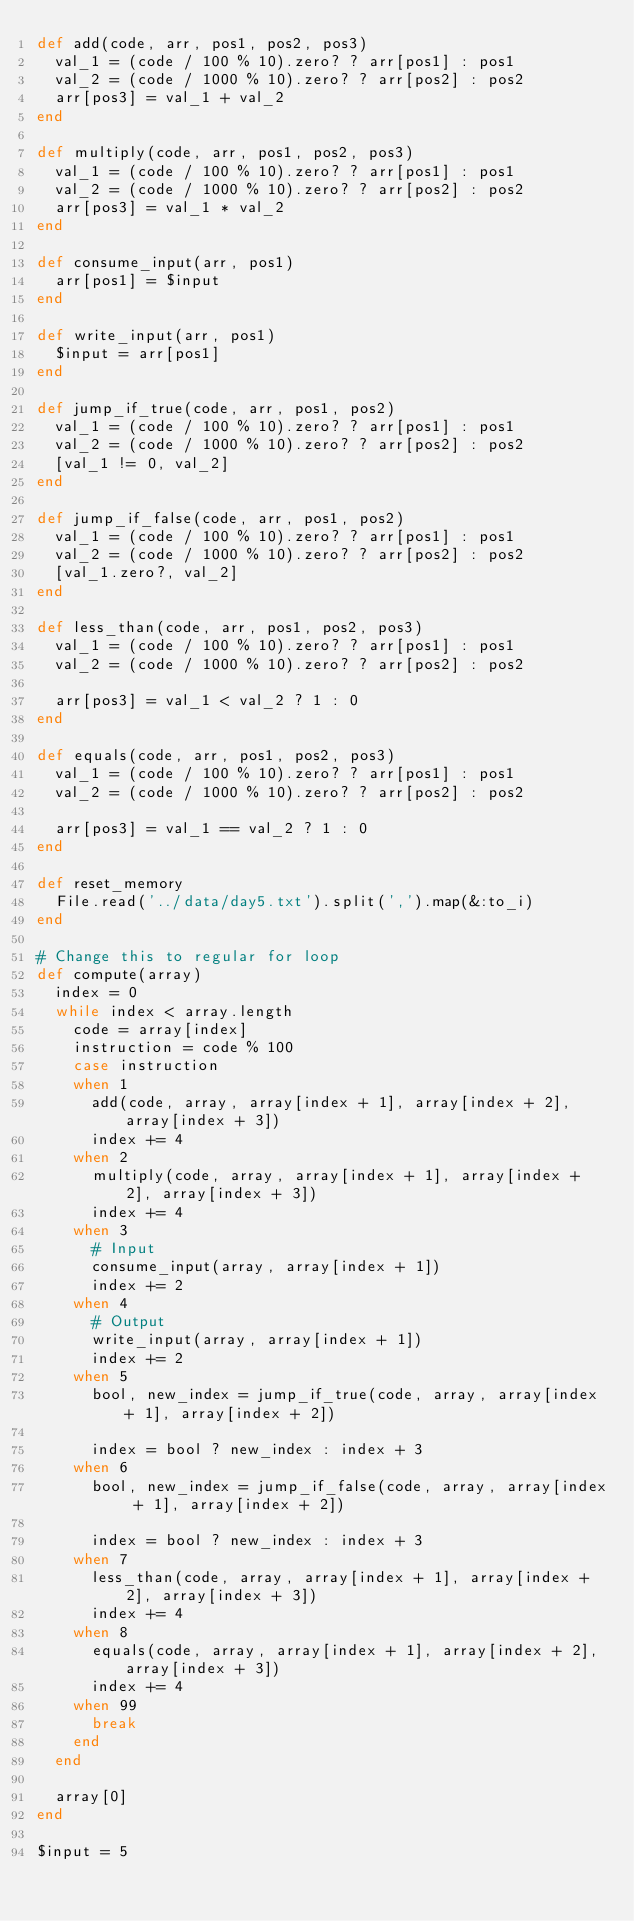Convert code to text. <code><loc_0><loc_0><loc_500><loc_500><_Ruby_>def add(code, arr, pos1, pos2, pos3)
  val_1 = (code / 100 % 10).zero? ? arr[pos1] : pos1
  val_2 = (code / 1000 % 10).zero? ? arr[pos2] : pos2
  arr[pos3] = val_1 + val_2
end

def multiply(code, arr, pos1, pos2, pos3)
  val_1 = (code / 100 % 10).zero? ? arr[pos1] : pos1
  val_2 = (code / 1000 % 10).zero? ? arr[pos2] : pos2
  arr[pos3] = val_1 * val_2
end

def consume_input(arr, pos1)
  arr[pos1] = $input
end

def write_input(arr, pos1)
  $input = arr[pos1]
end

def jump_if_true(code, arr, pos1, pos2)
  val_1 = (code / 100 % 10).zero? ? arr[pos1] : pos1
  val_2 = (code / 1000 % 10).zero? ? arr[pos2] : pos2
  [val_1 != 0, val_2]
end

def jump_if_false(code, arr, pos1, pos2)
  val_1 = (code / 100 % 10).zero? ? arr[pos1] : pos1
  val_2 = (code / 1000 % 10).zero? ? arr[pos2] : pos2
  [val_1.zero?, val_2]
end

def less_than(code, arr, pos1, pos2, pos3)
  val_1 = (code / 100 % 10).zero? ? arr[pos1] : pos1
  val_2 = (code / 1000 % 10).zero? ? arr[pos2] : pos2

  arr[pos3] = val_1 < val_2 ? 1 : 0
end

def equals(code, arr, pos1, pos2, pos3)
  val_1 = (code / 100 % 10).zero? ? arr[pos1] : pos1
  val_2 = (code / 1000 % 10).zero? ? arr[pos2] : pos2

  arr[pos3] = val_1 == val_2 ? 1 : 0
end

def reset_memory
  File.read('../data/day5.txt').split(',').map(&:to_i)
end

# Change this to regular for loop
def compute(array)
  index = 0
  while index < array.length
    code = array[index]
    instruction = code % 100
    case instruction
    when 1
      add(code, array, array[index + 1], array[index + 2], array[index + 3])
      index += 4
    when 2
      multiply(code, array, array[index + 1], array[index + 2], array[index + 3])
      index += 4
    when 3
      # Input
      consume_input(array, array[index + 1])
      index += 2
    when 4
      # Output
      write_input(array, array[index + 1])
      index += 2
    when 5
      bool, new_index = jump_if_true(code, array, array[index + 1], array[index + 2])

      index = bool ? new_index : index + 3
    when 6
      bool, new_index = jump_if_false(code, array, array[index + 1], array[index + 2])

      index = bool ? new_index : index + 3
    when 7
      less_than(code, array, array[index + 1], array[index + 2], array[index + 3])
      index += 4
    when 8
      equals(code, array, array[index + 1], array[index + 2], array[index + 3])
      index += 4
    when 99
      break
    end
  end 

  array[0]
end

$input = 5
</code> 